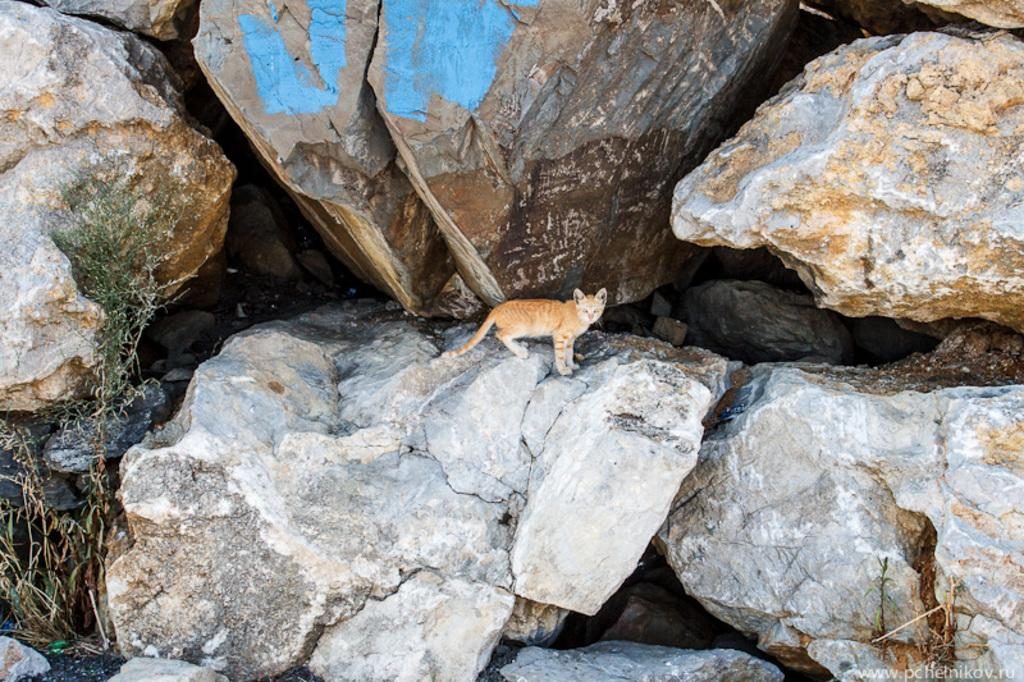What animal can be seen in the image? There is a cat on a rock in the image. What other object is present in the image? There is a plant on the left side of the image. Where is the watermark located in the image? The watermark is on the right side, bottom of the image. How many ducks are swimming in the water near the cat? There are no ducks present in the image. What emotion does the cat express towards the plant? The image does not convey any emotions, and there is no indication of the cat's feelings towards the plant. 